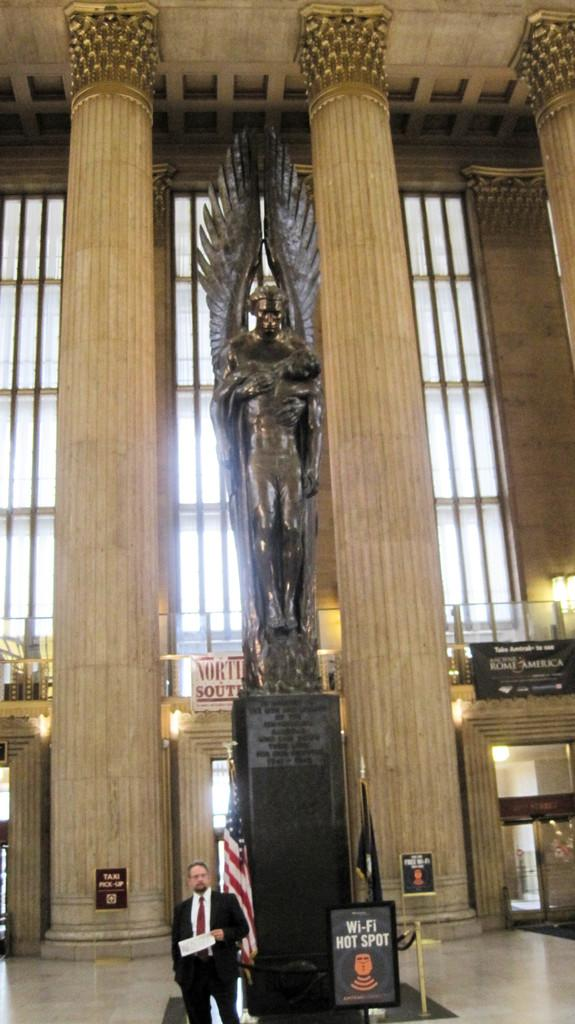What is the person in the image wearing? The person is wearing a suit. What is the person standing in front of? The person is standing in front of a statue. What can be seen behind the person? There is a flag behind the person. What architectural features are visible in the background of the image? There are windows and pillars in the background of the image. How many kittens are sitting on the person's lap in the image? There are no kittens present in the image. What type of store can be seen in the background of the image? There is no store visible in the image; it features a statue, a flag, and architectural features such as windows and pillars. 